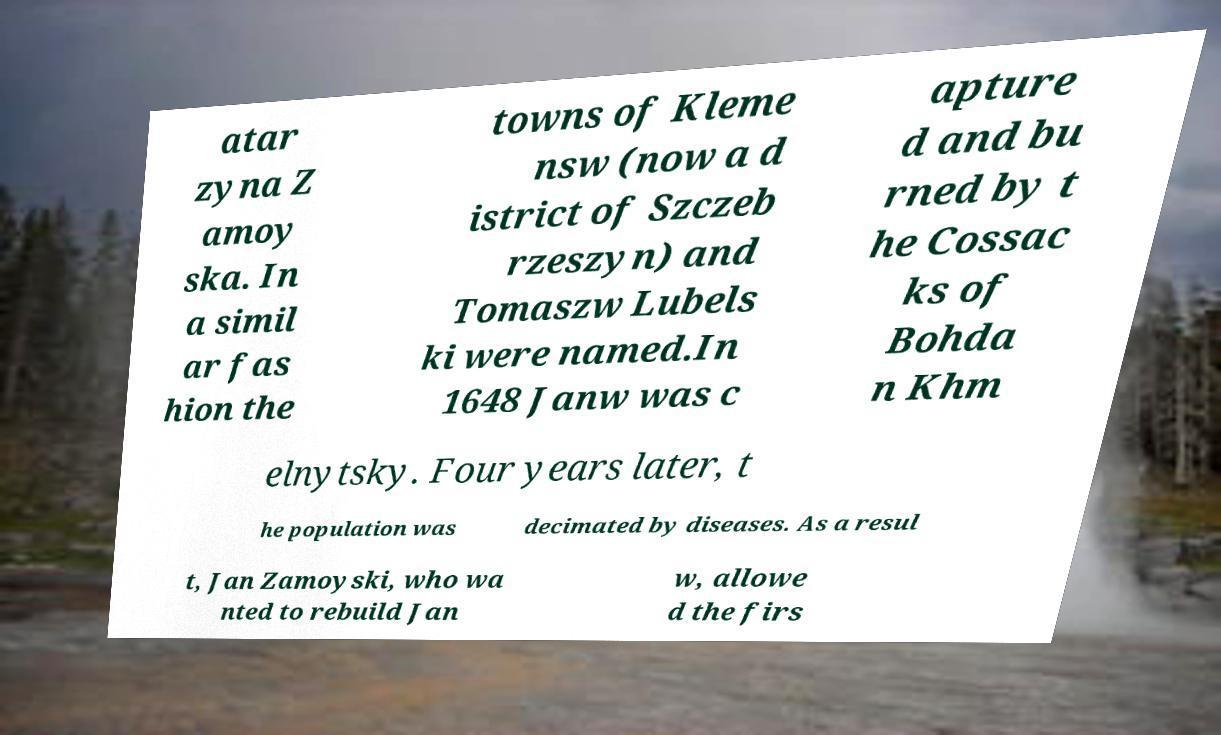Can you accurately transcribe the text from the provided image for me? atar zyna Z amoy ska. In a simil ar fas hion the towns of Kleme nsw (now a d istrict of Szczeb rzeszyn) and Tomaszw Lubels ki were named.In 1648 Janw was c apture d and bu rned by t he Cossac ks of Bohda n Khm elnytsky. Four years later, t he population was decimated by diseases. As a resul t, Jan Zamoyski, who wa nted to rebuild Jan w, allowe d the firs 